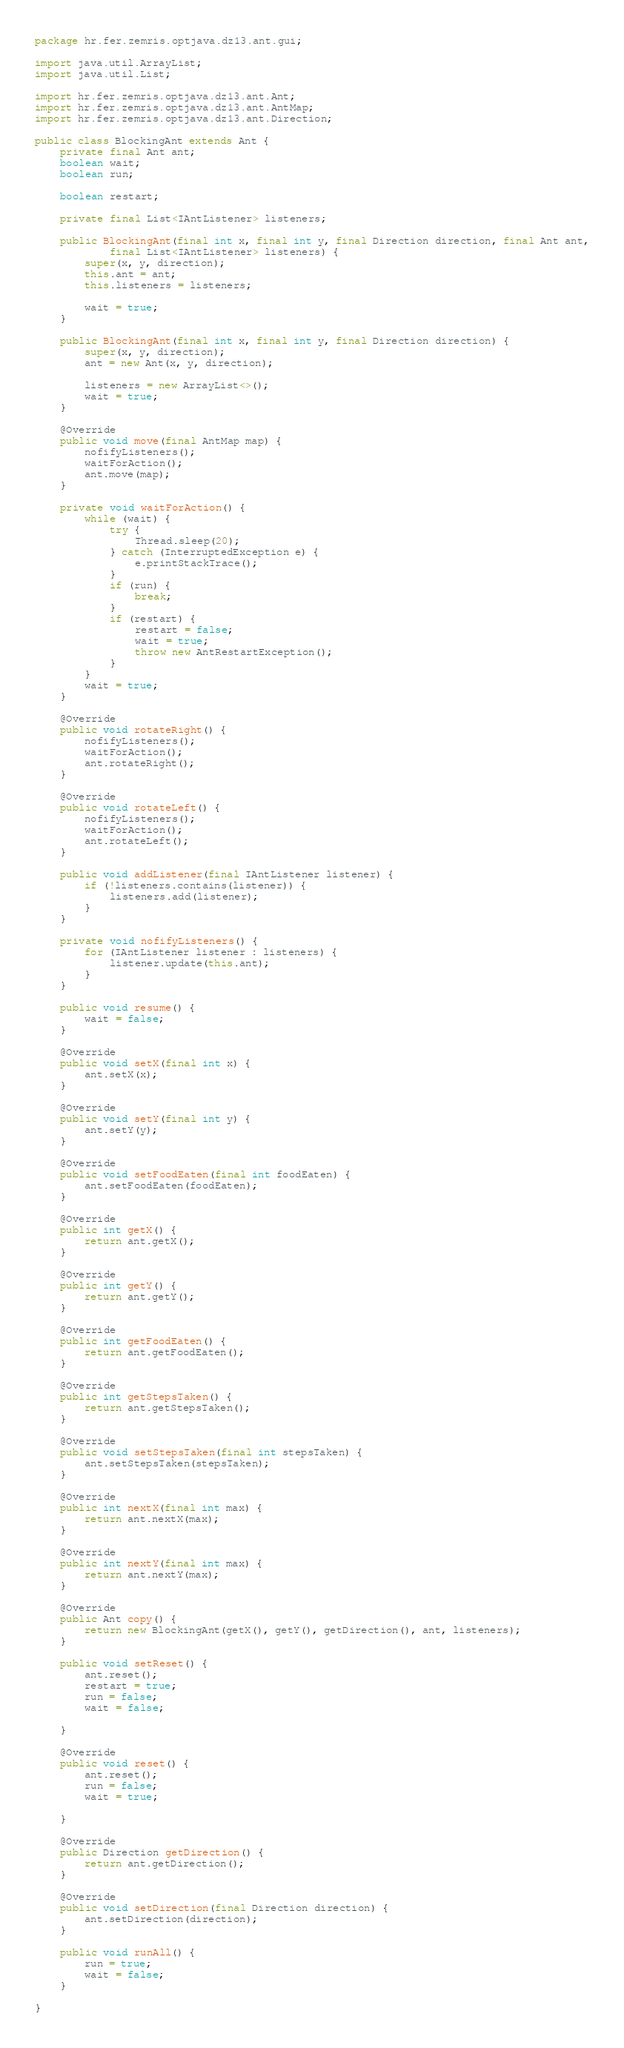Convert code to text. <code><loc_0><loc_0><loc_500><loc_500><_Java_>package hr.fer.zemris.optjava.dz13.ant.gui;

import java.util.ArrayList;
import java.util.List;

import hr.fer.zemris.optjava.dz13.ant.Ant;
import hr.fer.zemris.optjava.dz13.ant.AntMap;
import hr.fer.zemris.optjava.dz13.ant.Direction;

public class BlockingAnt extends Ant {
    private final Ant ant;
    boolean wait;
    boolean run;

    boolean restart;

    private final List<IAntListener> listeners;

    public BlockingAnt(final int x, final int y, final Direction direction, final Ant ant,
            final List<IAntListener> listeners) {
        super(x, y, direction);
        this.ant = ant;
        this.listeners = listeners;

        wait = true;
    }

    public BlockingAnt(final int x, final int y, final Direction direction) {
        super(x, y, direction);
        ant = new Ant(x, y, direction);

        listeners = new ArrayList<>();
        wait = true;
    }

    @Override
    public void move(final AntMap map) {
        nofifyListeners();
        waitForAction();
        ant.move(map);
    }

    private void waitForAction() {
        while (wait) {
            try {
                Thread.sleep(20);
            } catch (InterruptedException e) {
                e.printStackTrace();
            }
            if (run) {
                break;
            }
            if (restart) {
                restart = false;
                wait = true;
                throw new AntRestartException();
            }
        }
        wait = true;
    }

    @Override
    public void rotateRight() {
        nofifyListeners();
        waitForAction();
        ant.rotateRight();
    }

    @Override
    public void rotateLeft() {
        nofifyListeners();
        waitForAction();
        ant.rotateLeft();
    }

    public void addListener(final IAntListener listener) {
        if (!listeners.contains(listener)) {
            listeners.add(listener);
        }
    }

    private void nofifyListeners() {
        for (IAntListener listener : listeners) {
            listener.update(this.ant);
        }
    }

    public void resume() {
        wait = false;
    }

    @Override
    public void setX(final int x) {
        ant.setX(x);
    }

    @Override
    public void setY(final int y) {
        ant.setY(y);
    }

    @Override
    public void setFoodEaten(final int foodEaten) {
        ant.setFoodEaten(foodEaten);
    }

    @Override
    public int getX() {
        return ant.getX();
    }

    @Override
    public int getY() {
        return ant.getY();
    }

    @Override
    public int getFoodEaten() {
        return ant.getFoodEaten();
    }

    @Override
    public int getStepsTaken() {
        return ant.getStepsTaken();
    }

    @Override
    public void setStepsTaken(final int stepsTaken) {
        ant.setStepsTaken(stepsTaken);
    }

    @Override
    public int nextX(final int max) {
        return ant.nextX(max);
    }

    @Override
    public int nextY(final int max) {
        return ant.nextY(max);
    }

    @Override
    public Ant copy() {
        return new BlockingAnt(getX(), getY(), getDirection(), ant, listeners);
    }

    public void setReset() {
        ant.reset();
        restart = true;
        run = false;
        wait = false;

    }

    @Override
    public void reset() {
        ant.reset();
        run = false;
        wait = true;

    }

    @Override
    public Direction getDirection() {
        return ant.getDirection();
    }

    @Override
    public void setDirection(final Direction direction) {
        ant.setDirection(direction);
    }

    public void runAll() {
        run = true;
        wait = false;
    }

}
</code> 